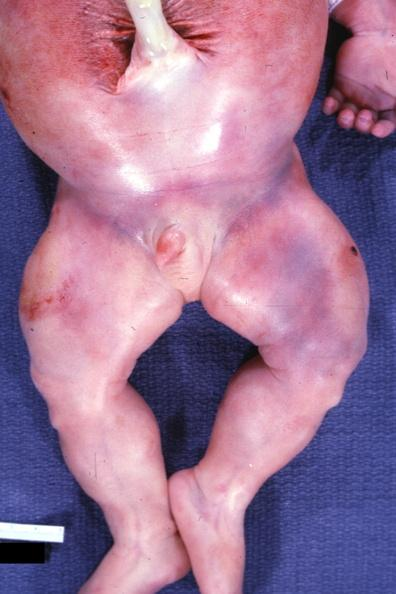what is present?
Answer the question using a single word or phrase. Beckwith-wiedemann syndrome 